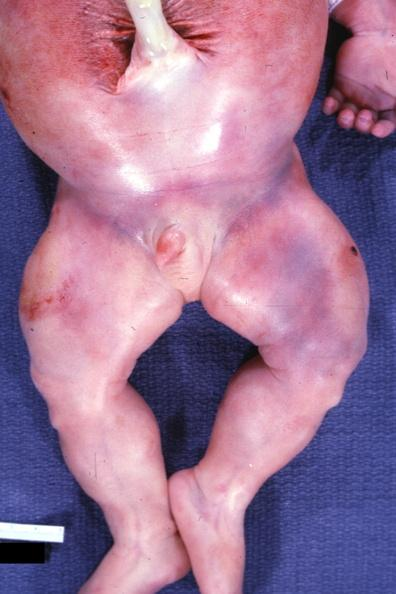what is present?
Answer the question using a single word or phrase. Beckwith-wiedemann syndrome 